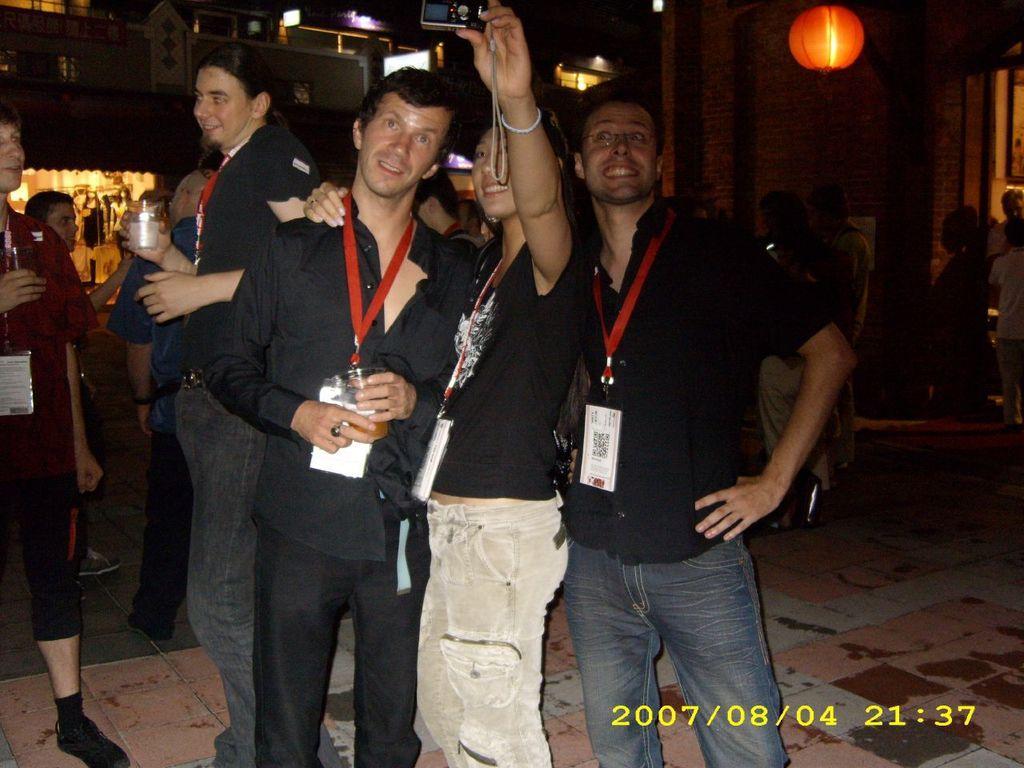Please provide a concise description of this image. There are three persons taking a snap with the camera. This is floor and there are few persons. In the background we can see buildings and lights. 